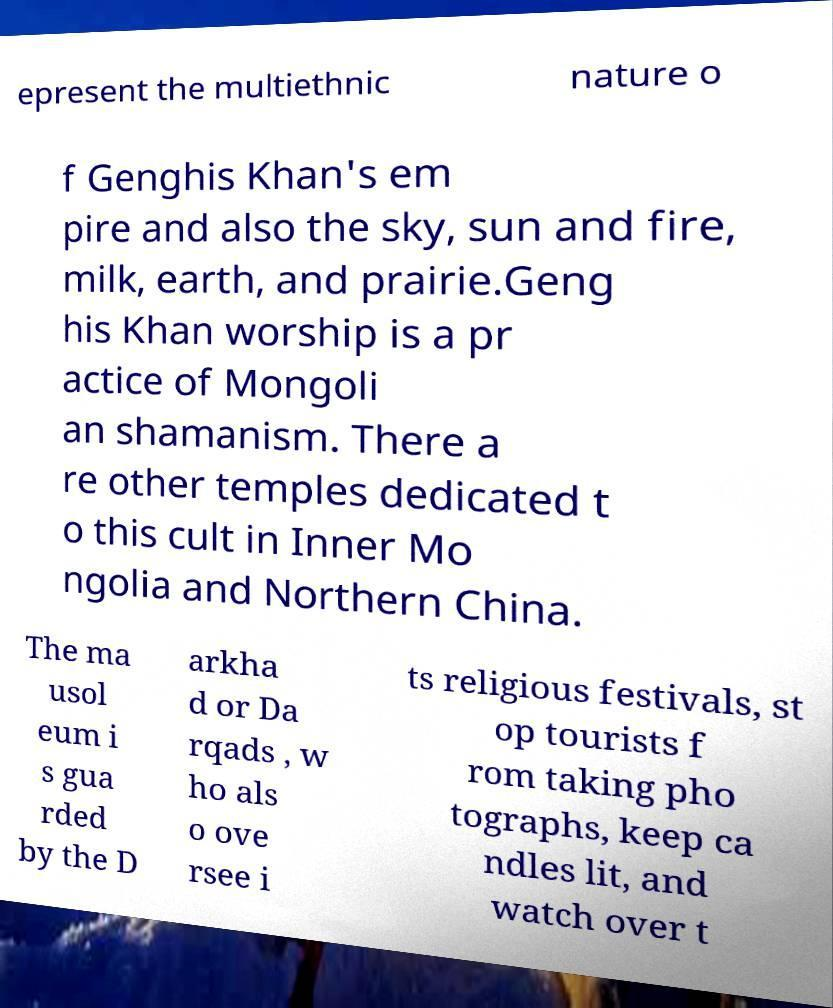There's text embedded in this image that I need extracted. Can you transcribe it verbatim? epresent the multiethnic nature o f Genghis Khan's em pire and also the sky, sun and fire, milk, earth, and prairie.Geng his Khan worship is a pr actice of Mongoli an shamanism. There a re other temples dedicated t o this cult in Inner Mo ngolia and Northern China. The ma usol eum i s gua rded by the D arkha d or Da rqads , w ho als o ove rsee i ts religious festivals, st op tourists f rom taking pho tographs, keep ca ndles lit, and watch over t 